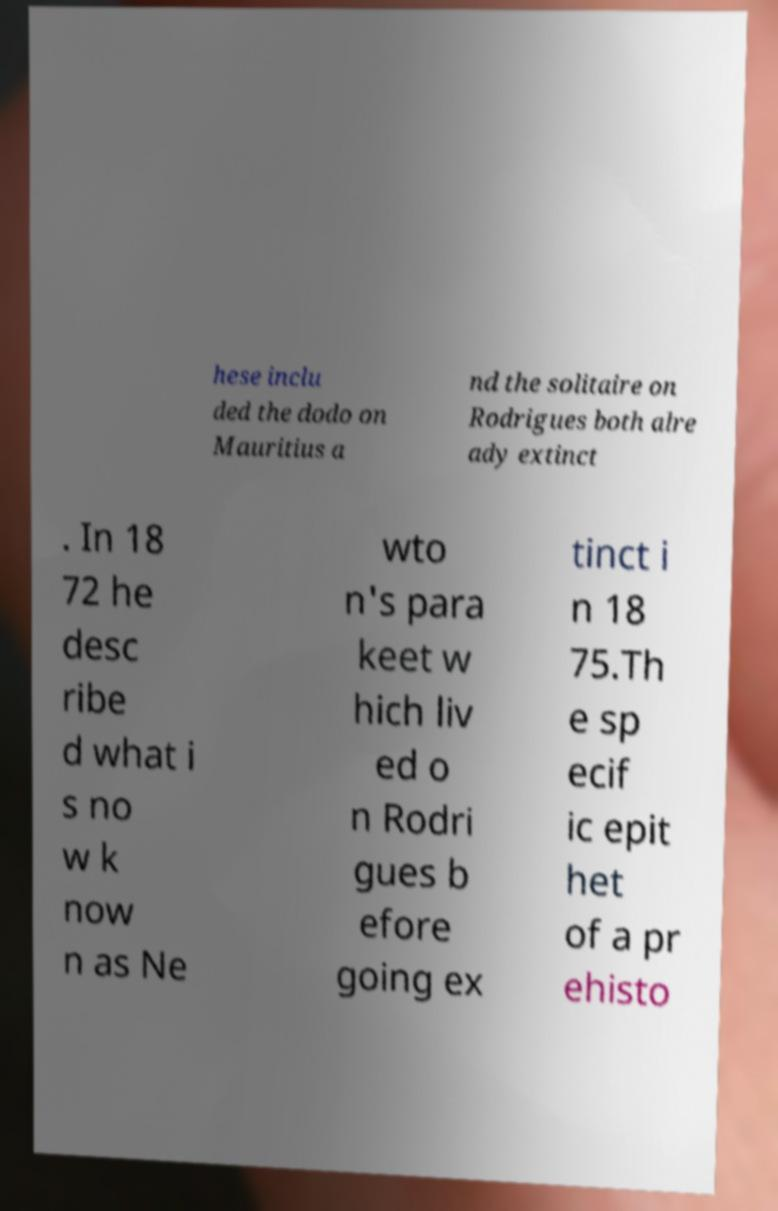Could you extract and type out the text from this image? hese inclu ded the dodo on Mauritius a nd the solitaire on Rodrigues both alre ady extinct . In 18 72 he desc ribe d what i s no w k now n as Ne wto n's para keet w hich liv ed o n Rodri gues b efore going ex tinct i n 18 75.Th e sp ecif ic epit het of a pr ehisto 